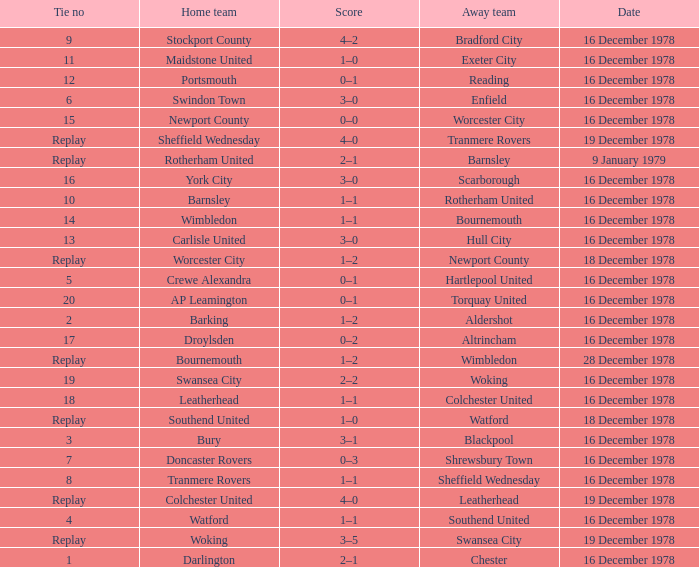Waht was the away team when the home team is colchester united? Leatherhead. 